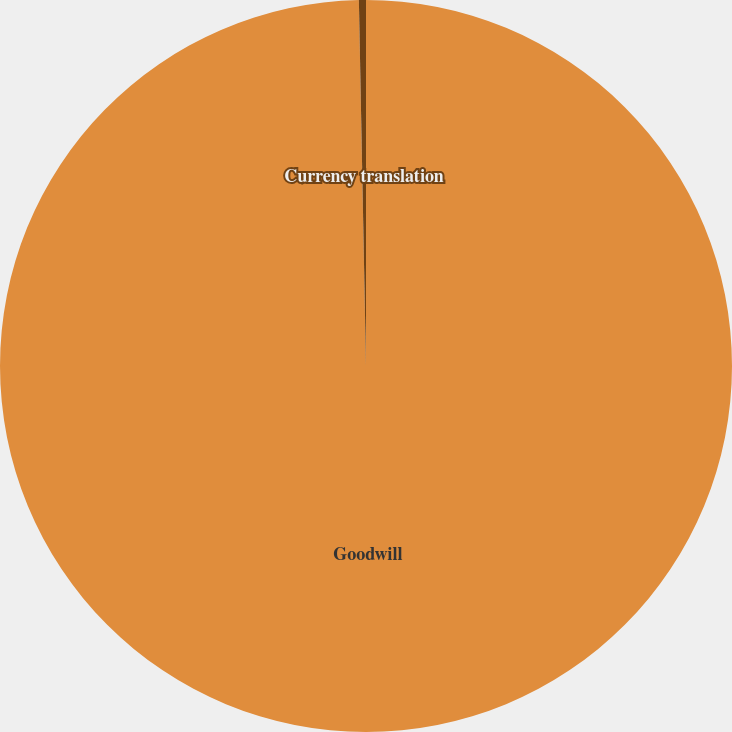<chart> <loc_0><loc_0><loc_500><loc_500><pie_chart><fcel>Goodwill<fcel>Currency translation<nl><fcel>99.69%<fcel>0.31%<nl></chart> 